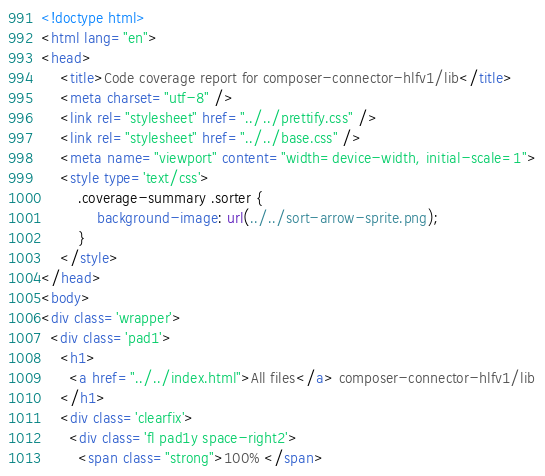Convert code to text. <code><loc_0><loc_0><loc_500><loc_500><_HTML_><!doctype html>
<html lang="en">
<head>
    <title>Code coverage report for composer-connector-hlfv1/lib</title>
    <meta charset="utf-8" />
    <link rel="stylesheet" href="../../prettify.css" />
    <link rel="stylesheet" href="../../base.css" />
    <meta name="viewport" content="width=device-width, initial-scale=1">
    <style type='text/css'>
        .coverage-summary .sorter {
            background-image: url(../../sort-arrow-sprite.png);
        }
    </style>
</head>
<body>
<div class='wrapper'>
  <div class='pad1'>
    <h1>
      <a href="../../index.html">All files</a> composer-connector-hlfv1/lib
    </h1>
    <div class='clearfix'>
      <div class='fl pad1y space-right2'>
        <span class="strong">100% </span></code> 